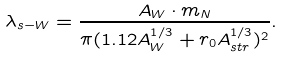<formula> <loc_0><loc_0><loc_500><loc_500>\lambda _ { s - W } = \frac { A _ { W } \cdot m _ { N } } { \pi ( 1 . 1 2 A ^ { 1 / 3 } _ { W } + r _ { 0 } A ^ { 1 / 3 } _ { s t r } ) ^ { 2 } } .</formula> 